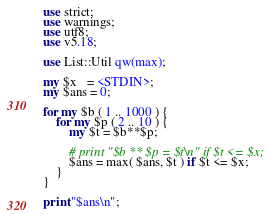<code> <loc_0><loc_0><loc_500><loc_500><_Perl_>use strict;
use warnings;
use utf8;
use v5.18;

use List::Util qw(max);

my $x   = <STDIN>;
my $ans = 0;

for my $b ( 1 .. 1000 ) {
    for my $p ( 2 .. 10 ) {
        my $t = $b**$p;

        # print "$b ** $p = $t\n" if $t <= $x;
        $ans = max( $ans, $t ) if $t <= $x;
    }
}

print "$ans\n";
</code> 